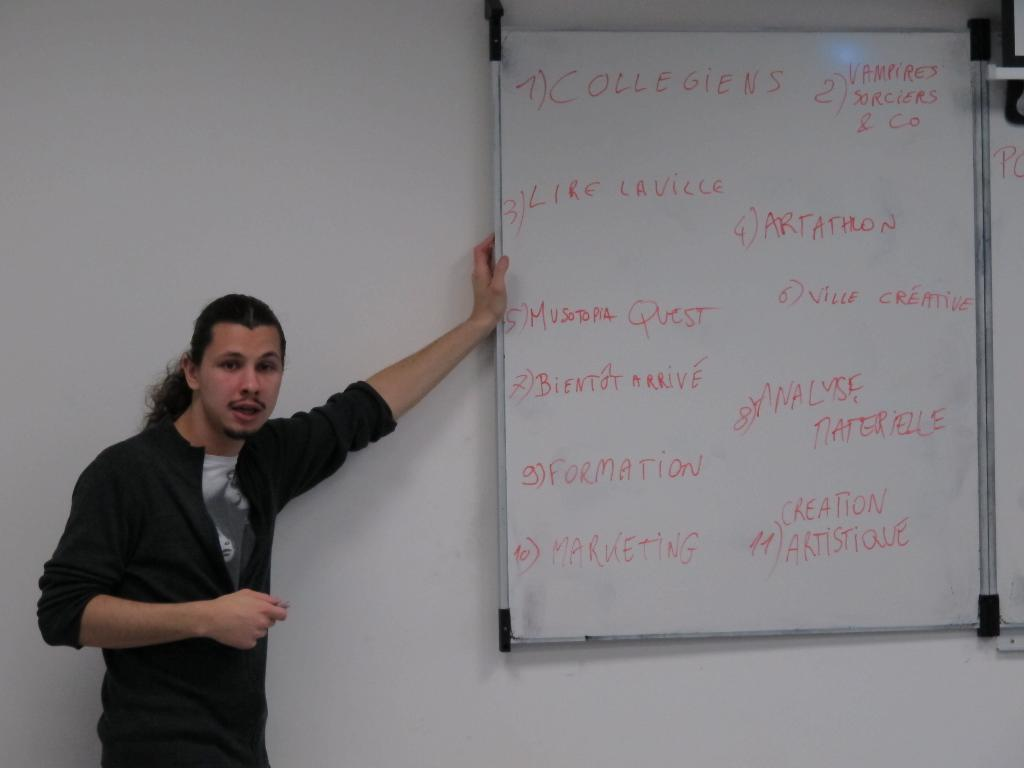<image>
Provide a brief description of the given image. A male presenter next to a whiteboard with Collegiens on it 